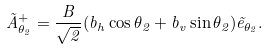<formula> <loc_0><loc_0><loc_500><loc_500>\vec { A } ^ { + } _ { \theta _ { 2 } } = \frac { B } { \sqrt { 2 } } ( b _ { h } \cos \theta _ { 2 } + b _ { v } \sin \theta _ { 2 } ) \vec { e } _ { \theta _ { 2 } } .</formula> 